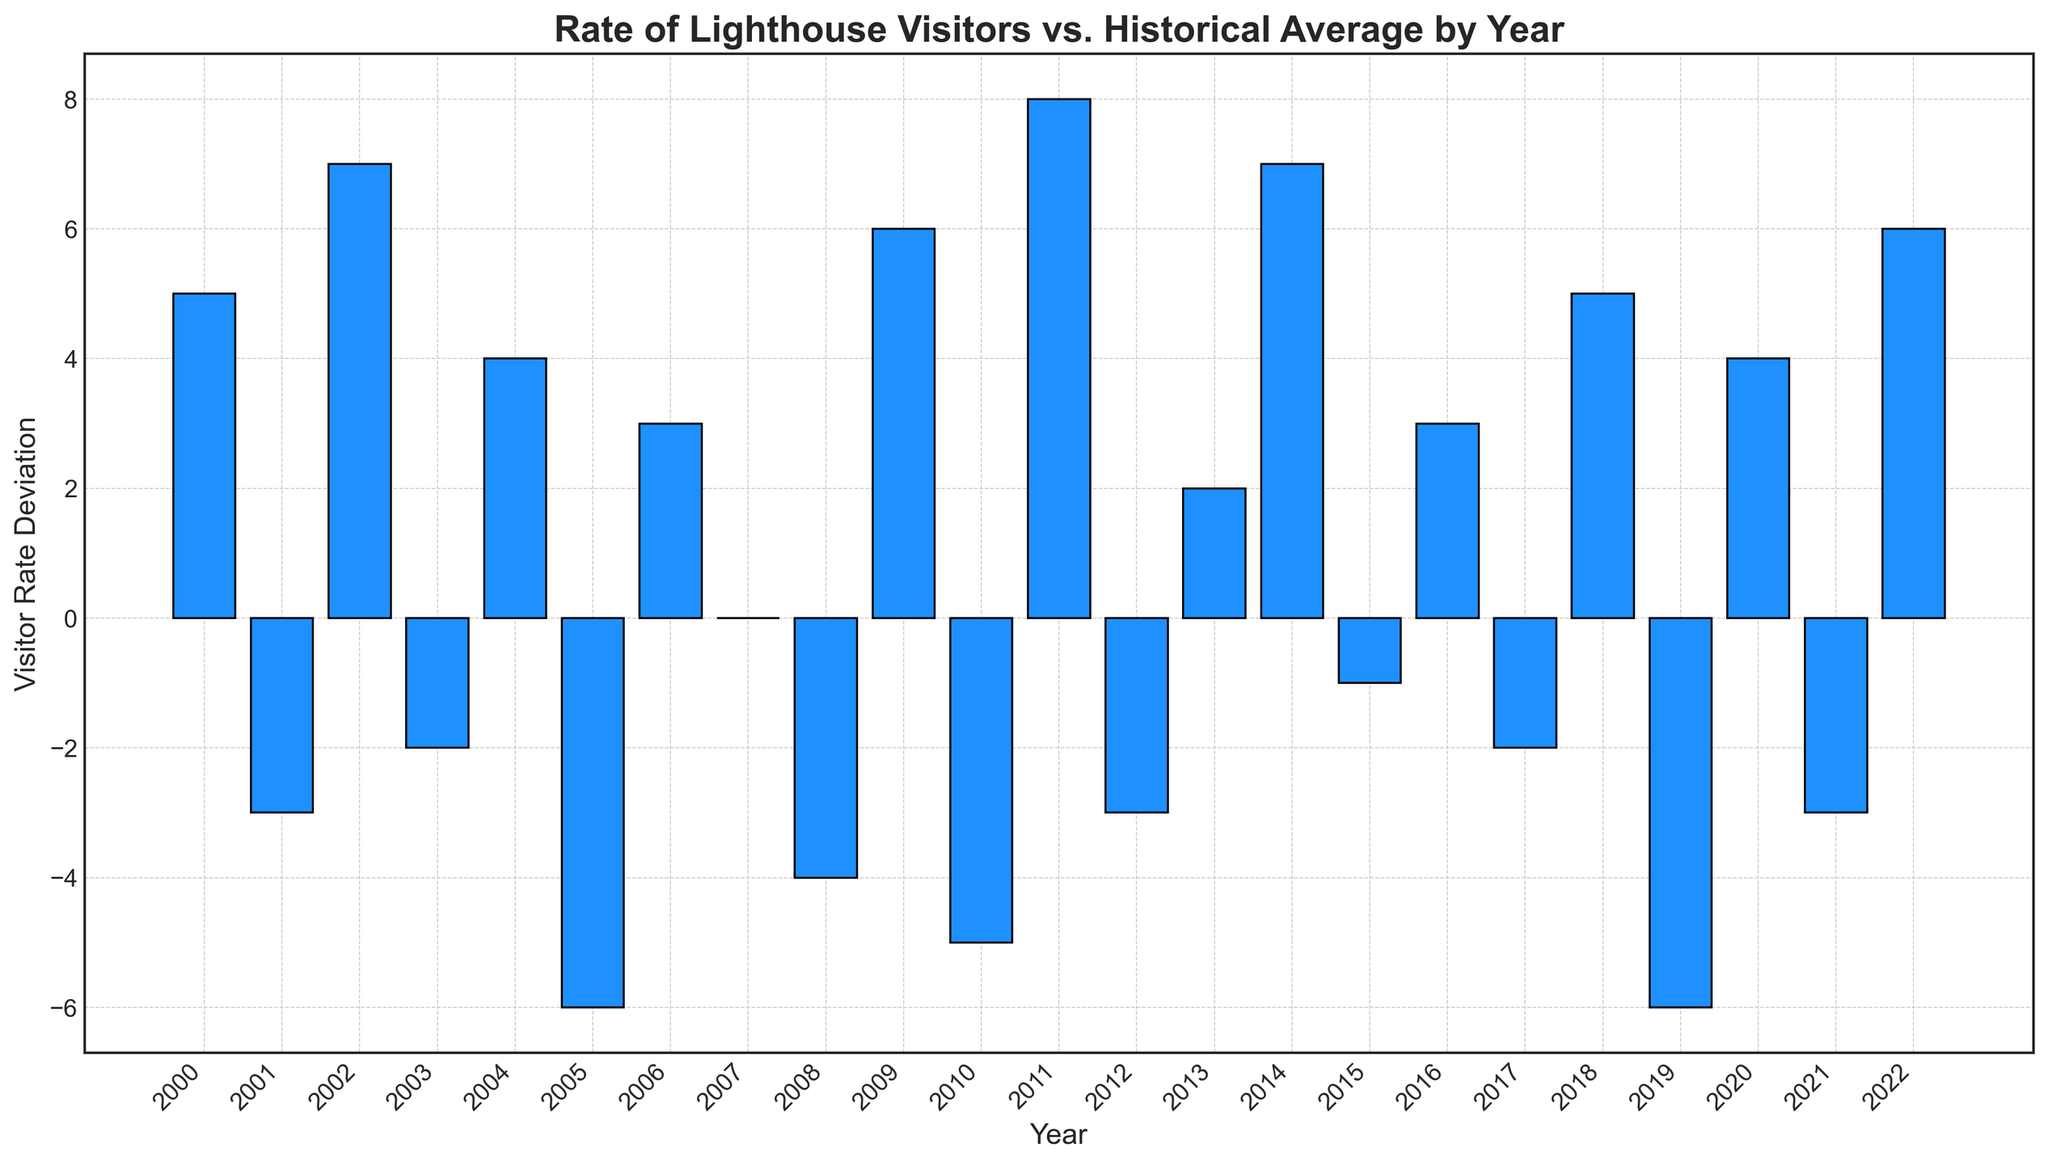What year had the highest visitor rate deviation from the historical average? The highest bar on the chart represents the year with the maximum deviation from the historical average. The tallest bar is in 2011, which shows a deviation of 8.
Answer: 2011 Which years had a visitor rate deviation of -6? To find the years with a deviation of -6, look for the bars that extend the farthest into the negative region of the y-axis. There are two such years: 2005 and 2019.
Answer: 2005 and 2019 What is the sum of the visitor rate deviations for the years 2008, 2009, and 2010? Sum the values for these years: -4 (2008) + 6 (2009) - 5 (2010). Calculating this gives -4 + 6 - 5 = -3.
Answer: -3 How many years had positive visitor rate deviations? Count the number of bars that extend above the zero line (positive deviation). There are 13 years with positive deviations (2000, 2002, 2004, 2006, 2009, 2011, 2013, 2014, 2016, 2018, 2020, 2022).
Answer: 13 Which year had a visitor rate deviation equal to zero? The bar that aligns with the zero line visually indicates the year of a deviation equal to zero. This year is 2007.
Answer: 2007 Are there more years with positive or negative visitor rate deviations? Count the number of bars above and below the zero line. There are 13 positive years and 9 negative years, so there are more years with positive deviations.
Answer: Positive By how much did the visitor rate deviation increase from 2001 to 2002? Compare the heights of the bars for 2001 and 2002. The deviation changed from -3 (2001) to 7 (2002), the difference is 7 - (-3) = 10.
Answer: 10 Which year had the largest negative visitor rate deviation and what was the value? Identify the longest bar extending below zero for the largest negative deviation. This is 2019 with a value of -6.
Answer: 2019, -6 How many times did the visitor rate deviation reach exactly 4? Count the number of bars with a height corresponding to a deviation of 4. These years are 2004, 2020. There are 2 instances.
Answer: 2 What is the percentage of years with a negative deviation compared to the total number of years? There are 9 years with negative deviations and 23 total years. The percentage is (9/23) * 100 ≈ 39.13%.
Answer: 39.13% 